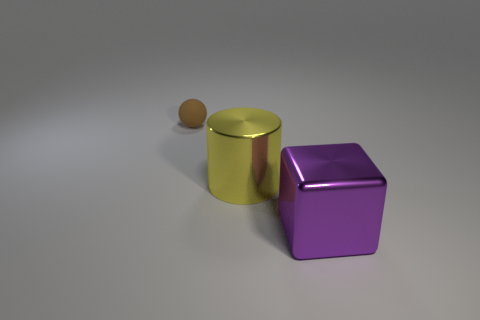Is there any other thing that is the same size as the matte ball?
Ensure brevity in your answer.  No. What is the color of the big shiny object behind the big purple object?
Ensure brevity in your answer.  Yellow. There is a cube; is its size the same as the object on the left side of the big cylinder?
Your answer should be very brief. No. What is the size of the object that is left of the cube and in front of the small rubber object?
Offer a very short reply. Large. Is there a blue cylinder made of the same material as the brown ball?
Keep it short and to the point. No. What shape is the tiny brown rubber thing?
Your answer should be compact. Sphere. Does the purple cube have the same size as the rubber ball?
Give a very brief answer. No. How many other things are the same shape as the large yellow object?
Ensure brevity in your answer.  0. There is a shiny object that is right of the metal cylinder; what shape is it?
Provide a short and direct response. Cube. Is the shape of the large metal thing that is behind the purple cube the same as the metal object that is right of the yellow metallic cylinder?
Offer a terse response. No. 